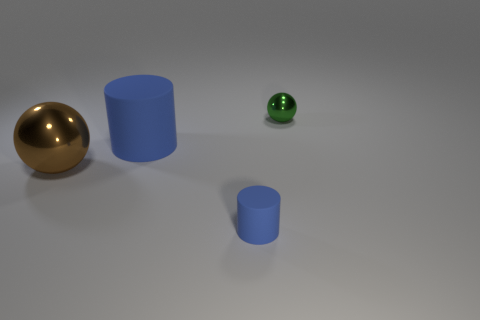Can you comment on the lighting and shadows in the image? The lighting in the image appears soft and uniform, casting gentle shadows that suggest an overhead diffuse light source. This creates a calm ambiance and helps to highlight the forms and textures of the objects. 